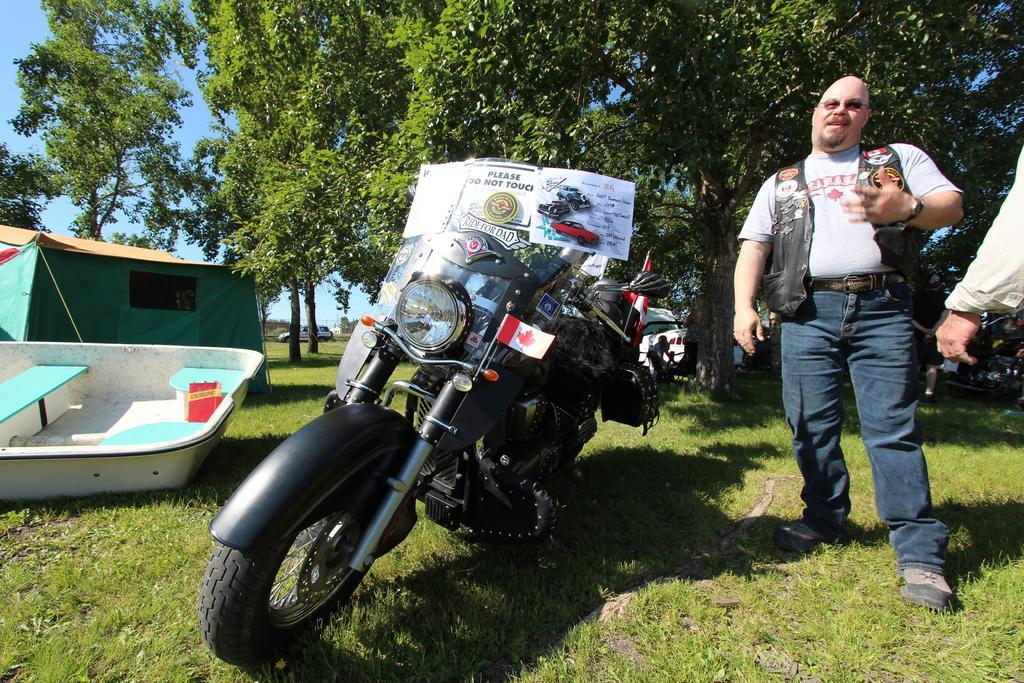Could you give a brief overview of what you see in this image? In this image I can see an open grass ground and on it I can see few vehicles. On the right side of this image I can see two persons are standing and on the left side I can see a boat and a tent house. On the motorcycle I can see a white colour board and on it I can see something is written. In the background I can see number of trees, a car and the sky. 